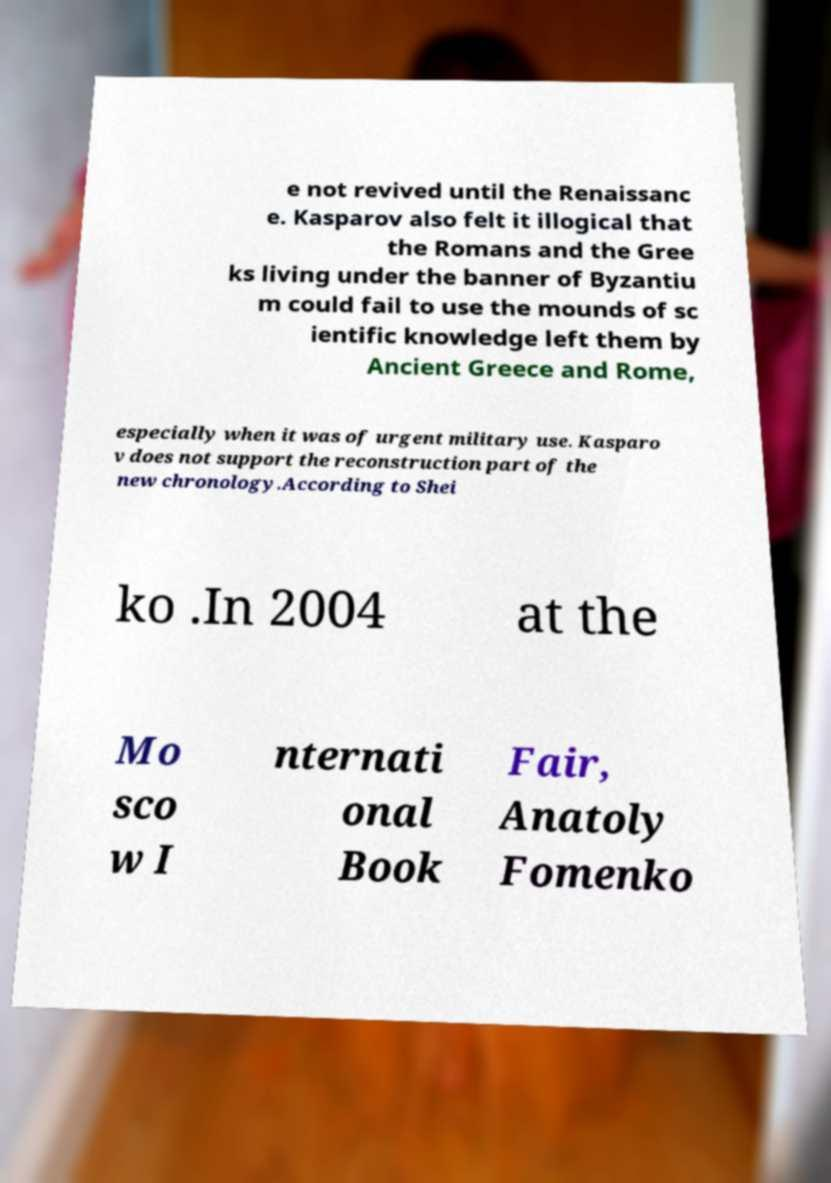Can you read and provide the text displayed in the image?This photo seems to have some interesting text. Can you extract and type it out for me? e not revived until the Renaissanc e. Kasparov also felt it illogical that the Romans and the Gree ks living under the banner of Byzantiu m could fail to use the mounds of sc ientific knowledge left them by Ancient Greece and Rome, especially when it was of urgent military use. Kasparo v does not support the reconstruction part of the new chronology.According to Shei ko .In 2004 at the Mo sco w I nternati onal Book Fair, Anatoly Fomenko 